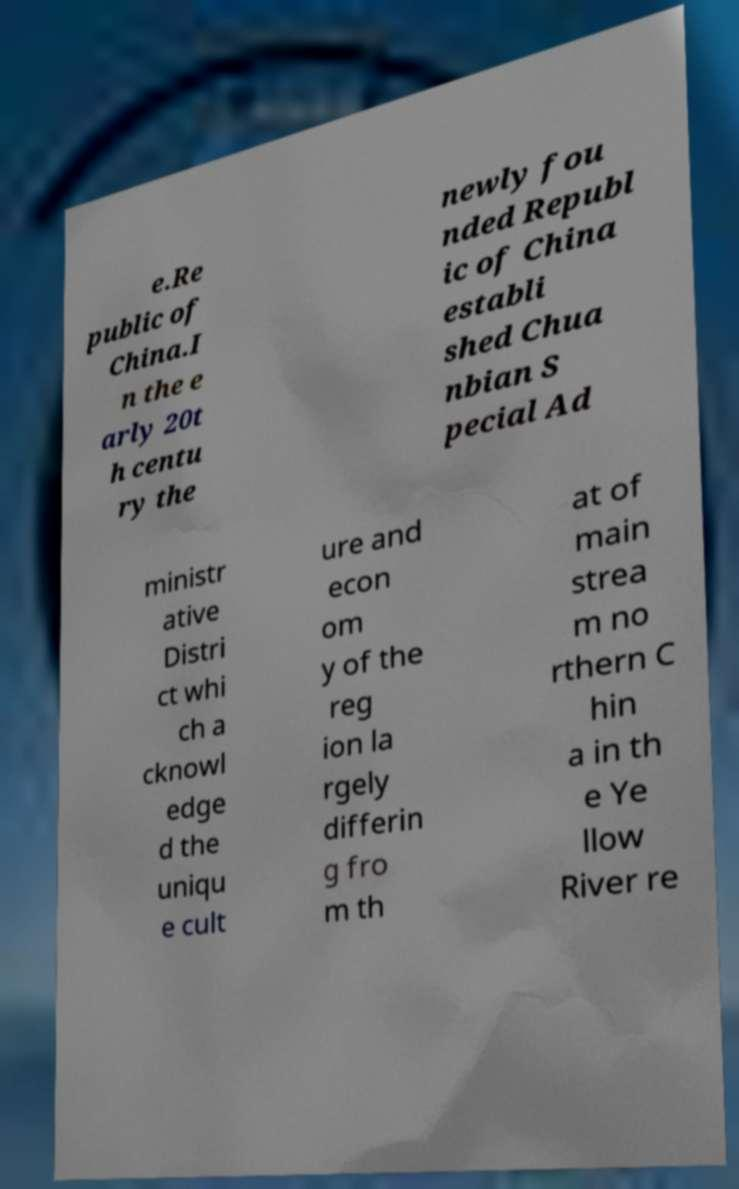Could you extract and type out the text from this image? e.Re public of China.I n the e arly 20t h centu ry the newly fou nded Republ ic of China establi shed Chua nbian S pecial Ad ministr ative Distri ct whi ch a cknowl edge d the uniqu e cult ure and econ om y of the reg ion la rgely differin g fro m th at of main strea m no rthern C hin a in th e Ye llow River re 